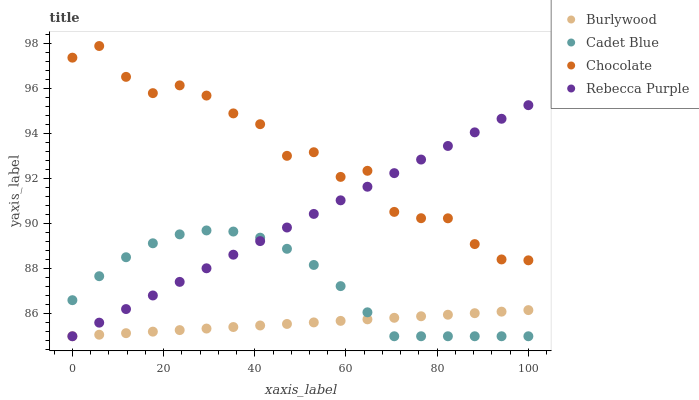Does Burlywood have the minimum area under the curve?
Answer yes or no. Yes. Does Chocolate have the maximum area under the curve?
Answer yes or no. Yes. Does Cadet Blue have the minimum area under the curve?
Answer yes or no. No. Does Cadet Blue have the maximum area under the curve?
Answer yes or no. No. Is Rebecca Purple the smoothest?
Answer yes or no. Yes. Is Chocolate the roughest?
Answer yes or no. Yes. Is Cadet Blue the smoothest?
Answer yes or no. No. Is Cadet Blue the roughest?
Answer yes or no. No. Does Burlywood have the lowest value?
Answer yes or no. Yes. Does Chocolate have the lowest value?
Answer yes or no. No. Does Chocolate have the highest value?
Answer yes or no. Yes. Does Cadet Blue have the highest value?
Answer yes or no. No. Is Cadet Blue less than Chocolate?
Answer yes or no. Yes. Is Chocolate greater than Cadet Blue?
Answer yes or no. Yes. Does Burlywood intersect Rebecca Purple?
Answer yes or no. Yes. Is Burlywood less than Rebecca Purple?
Answer yes or no. No. Is Burlywood greater than Rebecca Purple?
Answer yes or no. No. Does Cadet Blue intersect Chocolate?
Answer yes or no. No. 